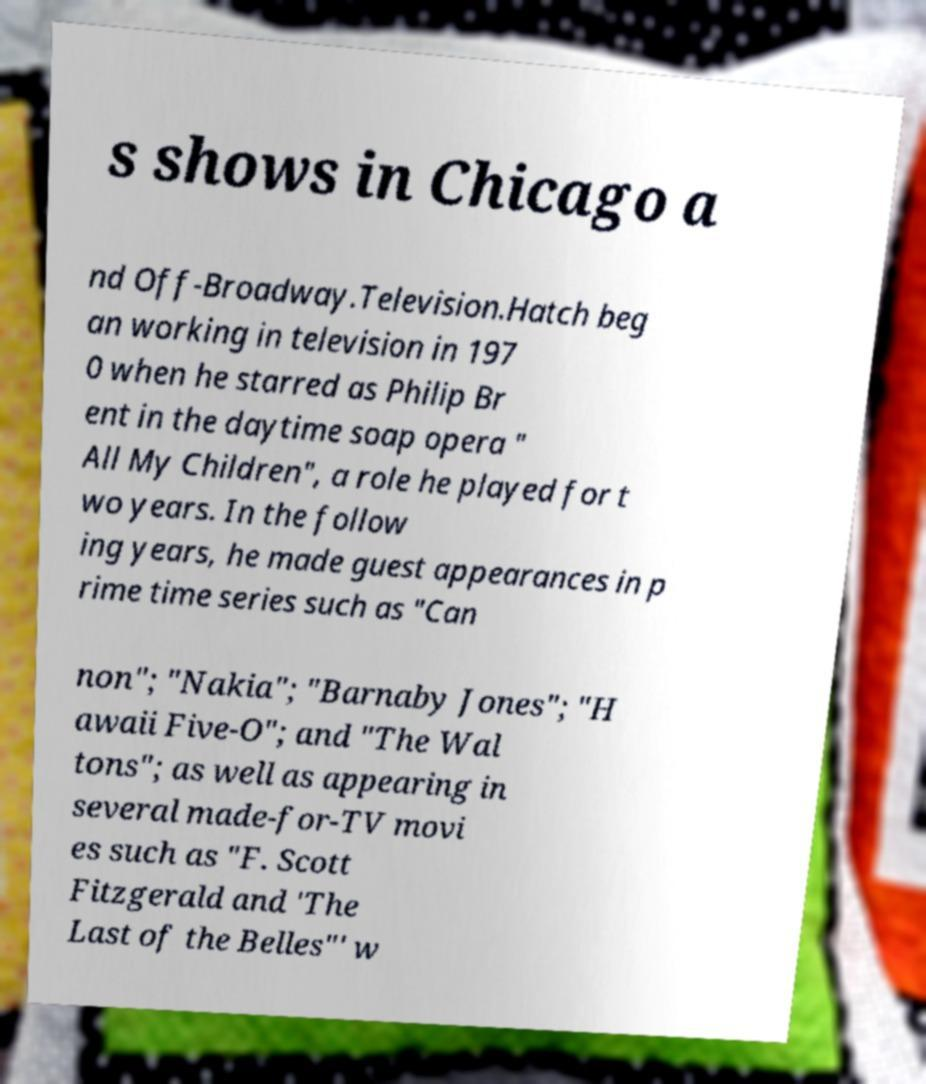Can you accurately transcribe the text from the provided image for me? s shows in Chicago a nd Off-Broadway.Television.Hatch beg an working in television in 197 0 when he starred as Philip Br ent in the daytime soap opera " All My Children", a role he played for t wo years. In the follow ing years, he made guest appearances in p rime time series such as "Can non"; "Nakia"; "Barnaby Jones"; "H awaii Five-O"; and "The Wal tons"; as well as appearing in several made-for-TV movi es such as "F. Scott Fitzgerald and 'The Last of the Belles"' w 